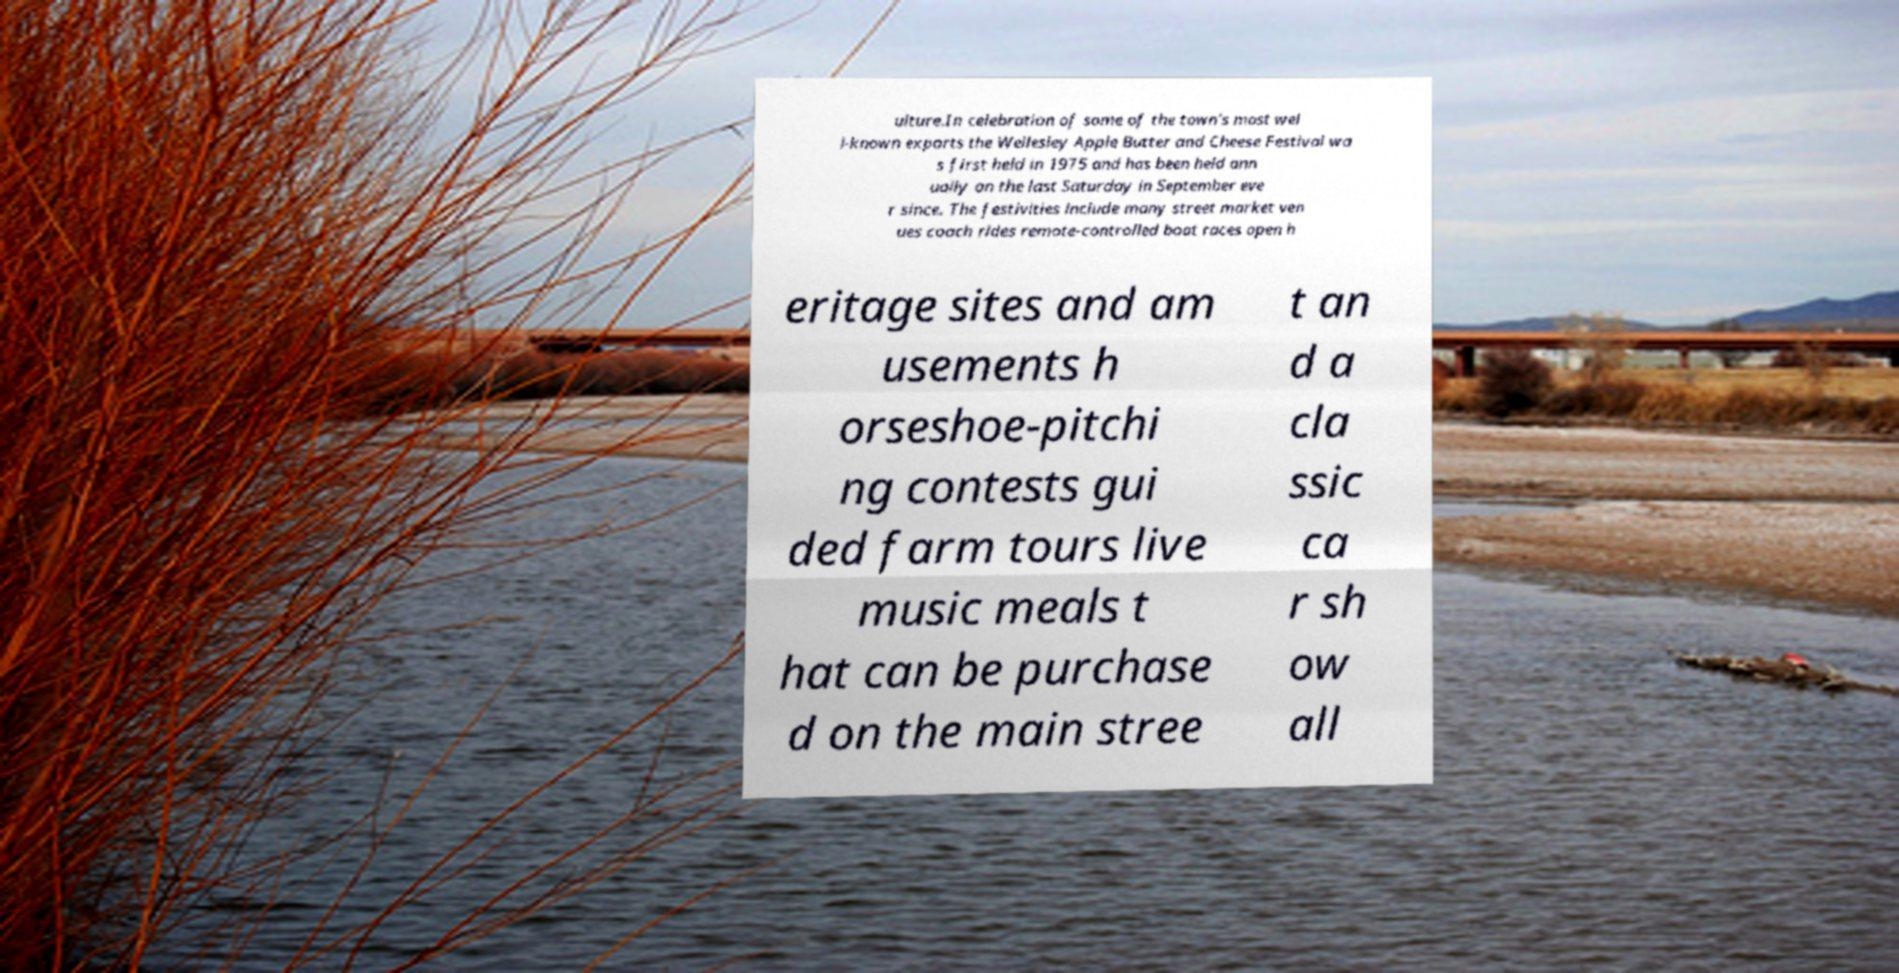Can you accurately transcribe the text from the provided image for me? ulture.In celebration of some of the town's most wel l-known exports the Wellesley Apple Butter and Cheese Festival wa s first held in 1975 and has been held ann ually on the last Saturday in September eve r since. The festivities include many street market ven ues coach rides remote-controlled boat races open h eritage sites and am usements h orseshoe-pitchi ng contests gui ded farm tours live music meals t hat can be purchase d on the main stree t an d a cla ssic ca r sh ow all 